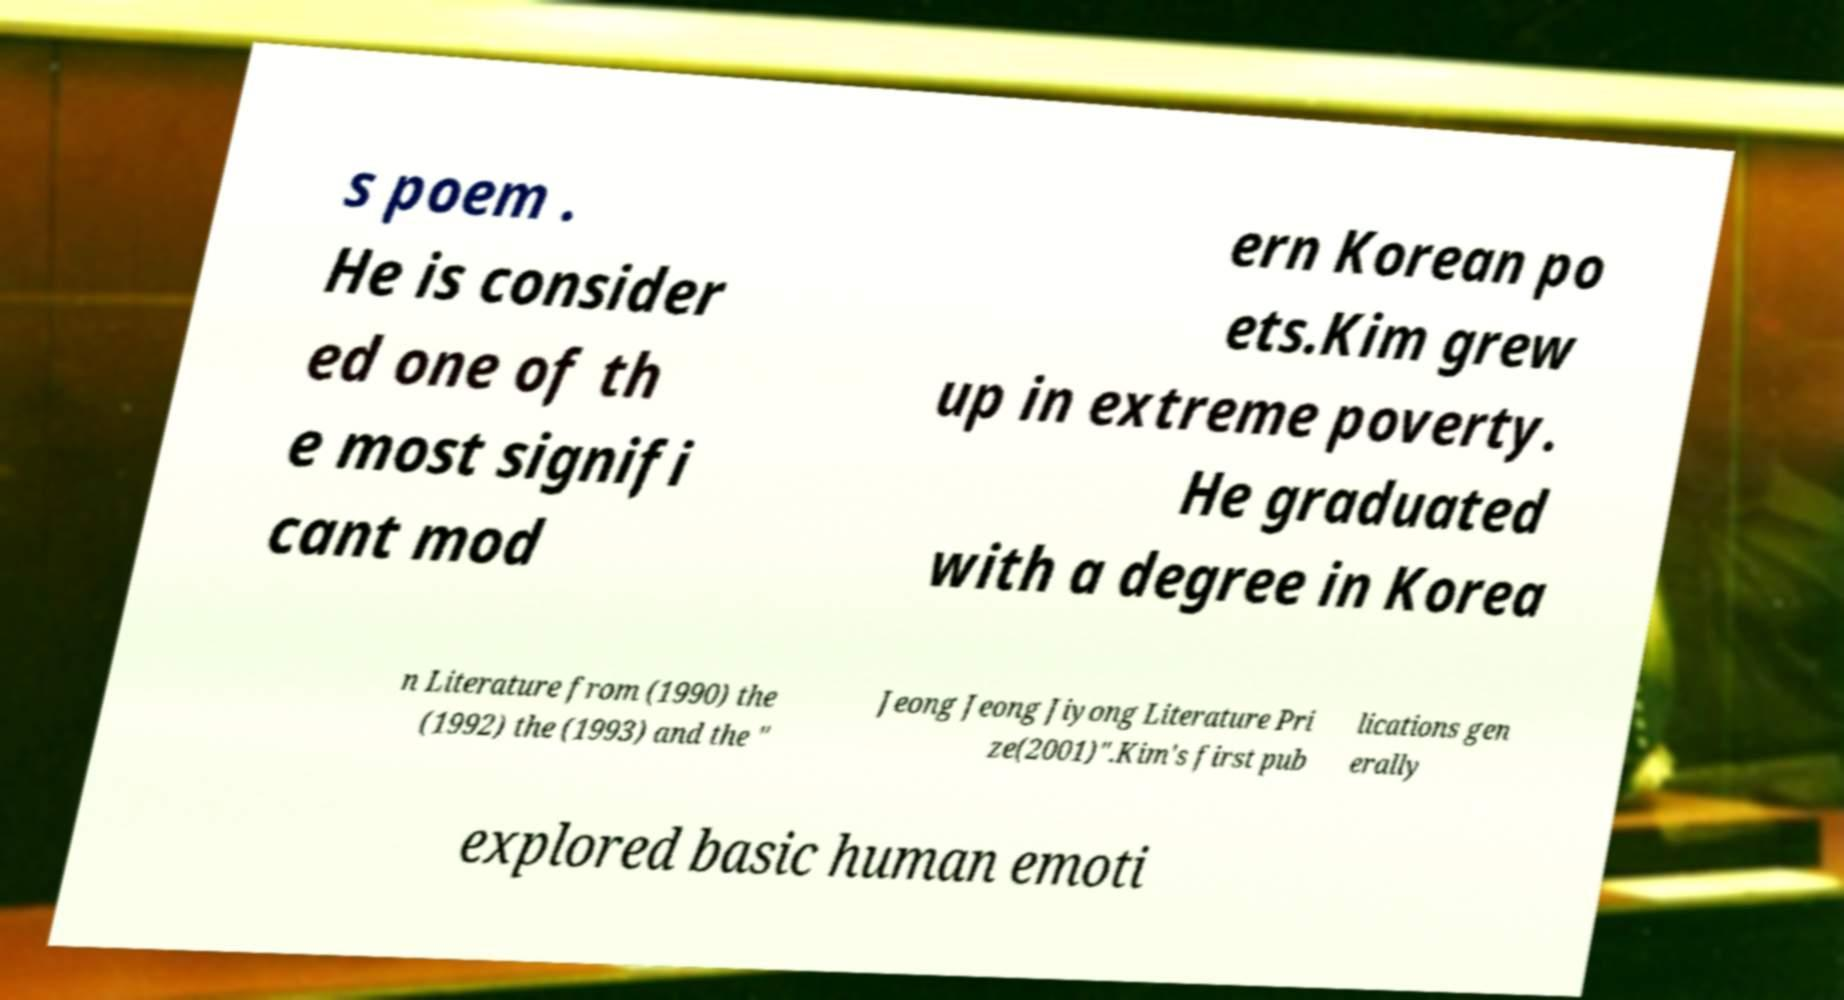Please read and relay the text visible in this image. What does it say? s poem . He is consider ed one of th e most signifi cant mod ern Korean po ets.Kim grew up in extreme poverty. He graduated with a degree in Korea n Literature from (1990) the (1992) the (1993) and the " Jeong Jeong Jiyong Literature Pri ze(2001)".Kim's first pub lications gen erally explored basic human emoti 